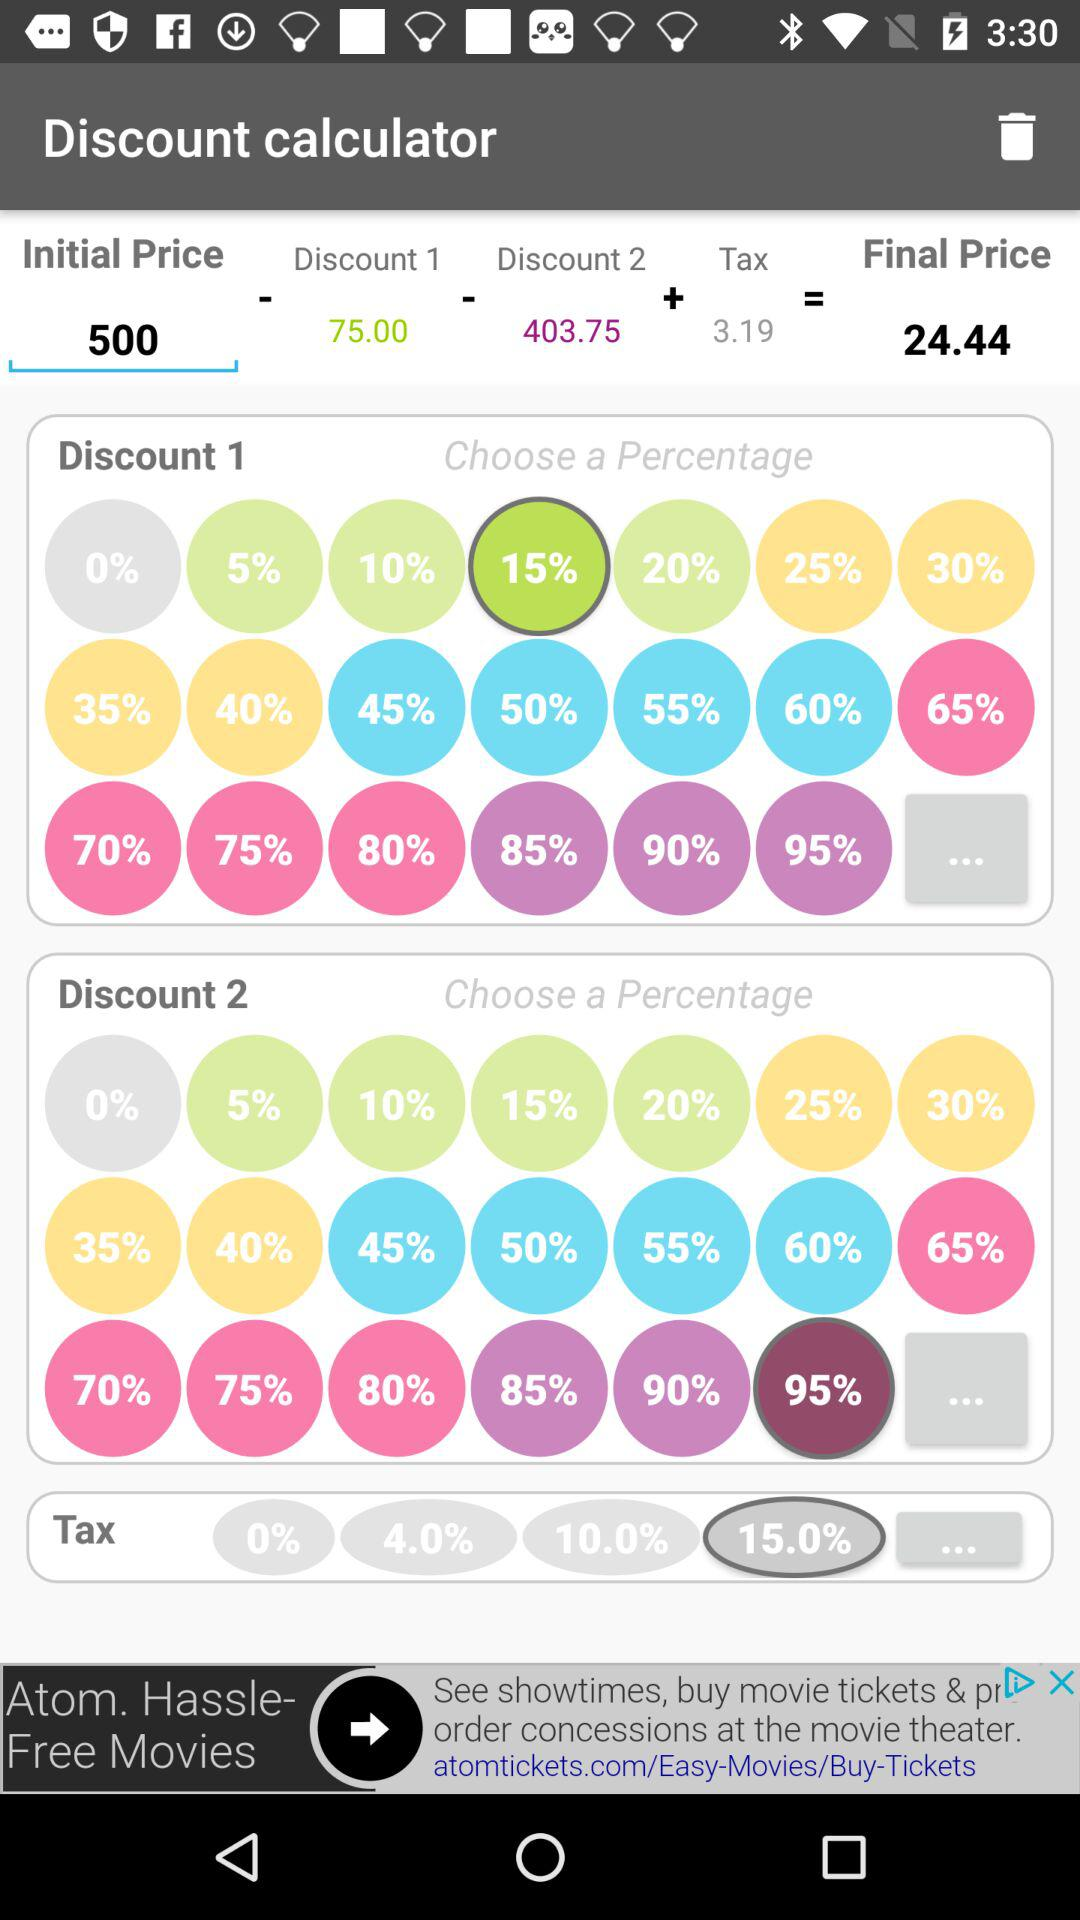How much is the tax? The tax is 3.19. 